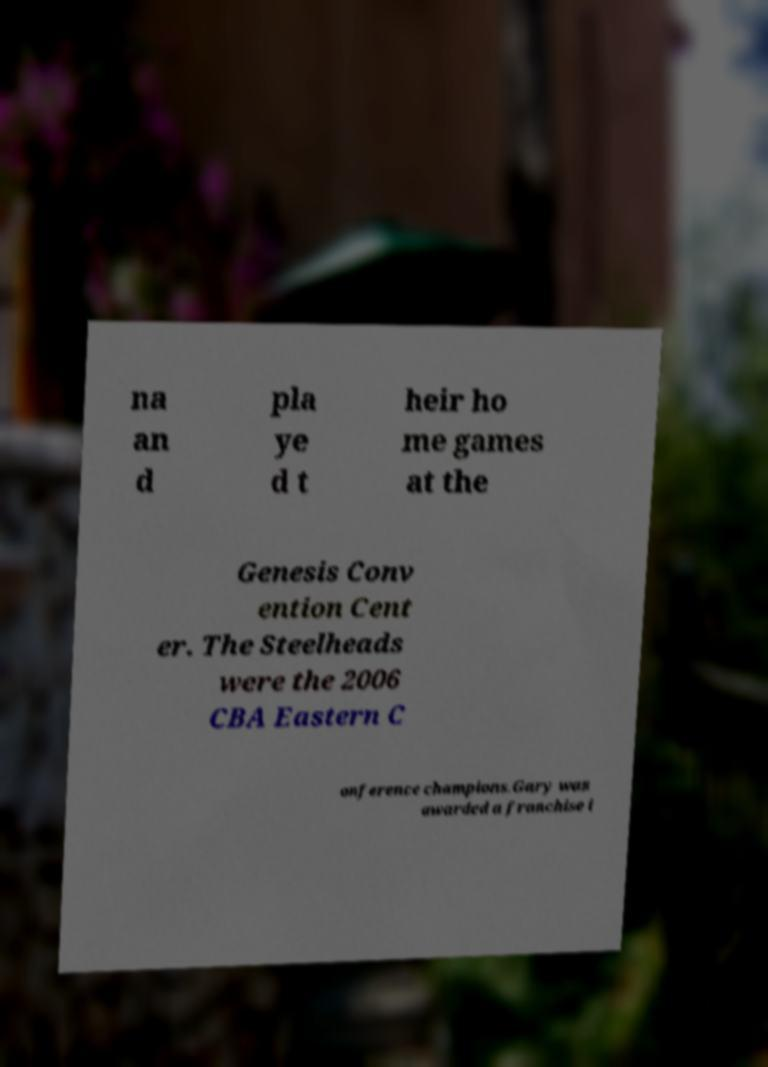For documentation purposes, I need the text within this image transcribed. Could you provide that? na an d pla ye d t heir ho me games at the Genesis Conv ention Cent er. The Steelheads were the 2006 CBA Eastern C onference champions.Gary was awarded a franchise i 